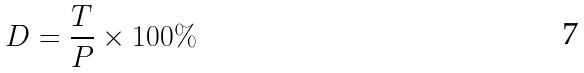Convert formula to latex. <formula><loc_0><loc_0><loc_500><loc_500>D = \frac { T } { P } \times 1 0 0 \%</formula> 